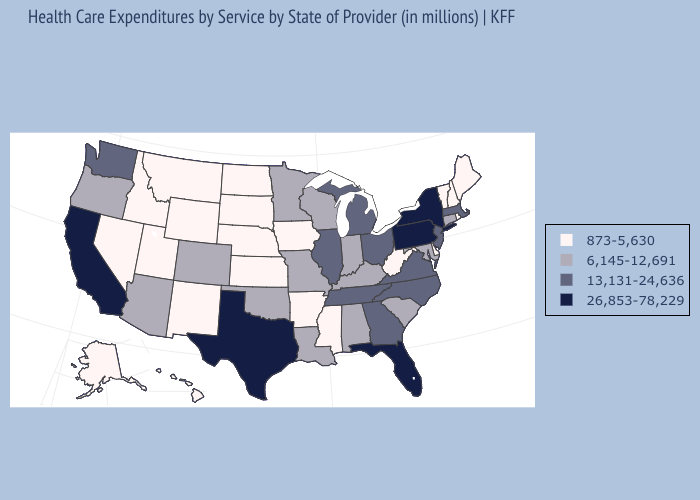Does Utah have the lowest value in the USA?
Quick response, please. Yes. What is the highest value in the West ?
Be succinct. 26,853-78,229. Name the states that have a value in the range 26,853-78,229?
Give a very brief answer. California, Florida, New York, Pennsylvania, Texas. Among the states that border Kansas , does Nebraska have the highest value?
Keep it brief. No. What is the lowest value in the USA?
Short answer required. 873-5,630. Name the states that have a value in the range 13,131-24,636?
Keep it brief. Georgia, Illinois, Massachusetts, Michigan, New Jersey, North Carolina, Ohio, Tennessee, Virginia, Washington. Does Tennessee have a higher value than Hawaii?
Be succinct. Yes. Among the states that border Texas , does Arkansas have the highest value?
Concise answer only. No. Among the states that border Wisconsin , which have the lowest value?
Write a very short answer. Iowa. Does Michigan have the highest value in the MidWest?
Be succinct. Yes. Which states have the highest value in the USA?
Short answer required. California, Florida, New York, Pennsylvania, Texas. Name the states that have a value in the range 13,131-24,636?
Quick response, please. Georgia, Illinois, Massachusetts, Michigan, New Jersey, North Carolina, Ohio, Tennessee, Virginia, Washington. What is the lowest value in states that border Utah?
Write a very short answer. 873-5,630. Does Florida have the same value as Texas?
Write a very short answer. Yes. What is the highest value in the MidWest ?
Concise answer only. 13,131-24,636. 